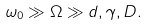Convert formula to latex. <formula><loc_0><loc_0><loc_500><loc_500>\omega _ { 0 } \gg \Omega \gg d , \gamma , D .</formula> 